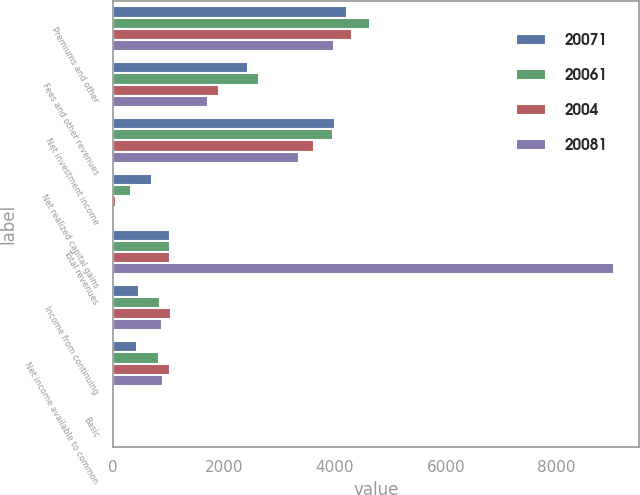<chart> <loc_0><loc_0><loc_500><loc_500><stacked_bar_chart><ecel><fcel>Premiums and other<fcel>Fees and other revenues<fcel>Net investment income<fcel>Net realized capital gains<fcel>Total revenues<fcel>Income from continuing<fcel>Net income available to common<fcel>Basic<nl><fcel>20071<fcel>4209.2<fcel>2426.5<fcel>3994.3<fcel>694.1<fcel>1031.3<fcel>458.1<fcel>425.1<fcel>1.64<nl><fcel>20061<fcel>4634.1<fcel>2634.7<fcel>3966.5<fcel>328.8<fcel>1031.3<fcel>840.1<fcel>827.3<fcel>3.04<nl><fcel>2004<fcel>4305.3<fcel>1902.5<fcel>3620.6<fcel>44.7<fcel>1031.3<fcel>1035.4<fcel>1031.3<fcel>3.67<nl><fcel>20081<fcel>3975<fcel>1717.8<fcel>3358<fcel>11.2<fcel>9039.6<fcel>890.2<fcel>901.3<fcel>3.03<nl></chart> 